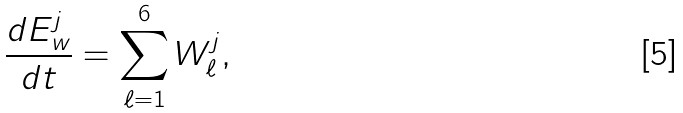Convert formula to latex. <formula><loc_0><loc_0><loc_500><loc_500>\frac { d E ^ { j } _ { w } } { d t } = \sum _ { \ell = 1 } ^ { 6 } W ^ { j } _ { \ell } ,</formula> 